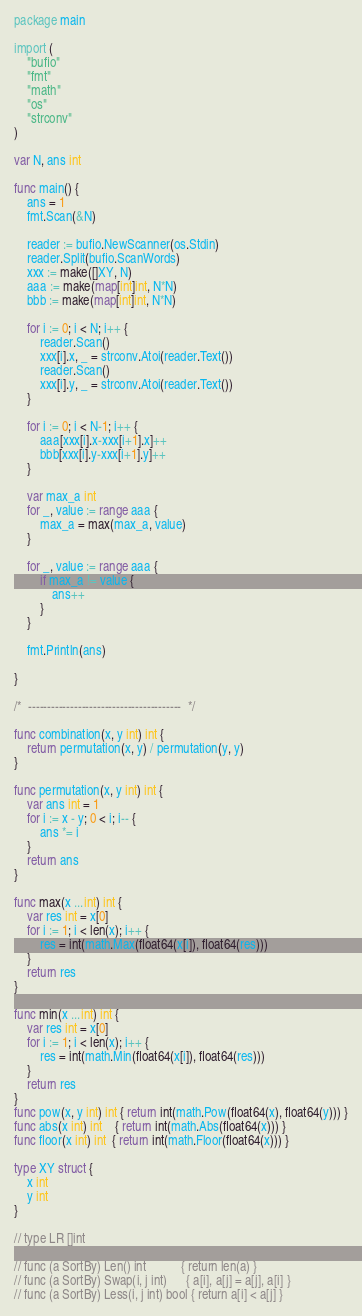Convert code to text. <code><loc_0><loc_0><loc_500><loc_500><_Go_>package main

import (
	"bufio"
	"fmt"
	"math"
	"os"
	"strconv"
)

var N, ans int

func main() {
	ans = 1
	fmt.Scan(&N)

	reader := bufio.NewScanner(os.Stdin)
	reader.Split(bufio.ScanWords)
	xxx := make([]XY, N)
	aaa := make(map[int]int, N*N)
	bbb := make(map[int]int, N*N)

	for i := 0; i < N; i++ {
		reader.Scan()
		xxx[i].x, _ = strconv.Atoi(reader.Text())
		reader.Scan()
		xxx[i].y, _ = strconv.Atoi(reader.Text())
	}

	for i := 0; i < N-1; i++ {
		aaa[xxx[i].x-xxx[i+1].x]++
		bbb[xxx[i].y-xxx[i+1].y]++
	}

	var max_a int
	for _, value := range aaa {
		max_a = max(max_a, value)
	}

	for _, value := range aaa {
		if max_a != value {
			ans++
		}
	}

	fmt.Println(ans)

}

/*  ----------------------------------------  */

func combination(x, y int) int {
	return permutation(x, y) / permutation(y, y)
}

func permutation(x, y int) int {
	var ans int = 1
	for i := x - y; 0 < i; i-- {
		ans *= i
	}
	return ans
}

func max(x ...int) int {
	var res int = x[0]
	for i := 1; i < len(x); i++ {
		res = int(math.Max(float64(x[i]), float64(res)))
	}
	return res
}

func min(x ...int) int {
	var res int = x[0]
	for i := 1; i < len(x); i++ {
		res = int(math.Min(float64(x[i]), float64(res)))
	}
	return res
}
func pow(x, y int) int { return int(math.Pow(float64(x), float64(y))) }
func abs(x int) int    { return int(math.Abs(float64(x))) }
func floor(x int) int  { return int(math.Floor(float64(x))) }

type XY struct {
	x int
	y int
}

// type LR []int

// func (a SortBy) Len() int           { return len(a) }
// func (a SortBy) Swap(i, j int)      { a[i], a[j] = a[j], a[i] }
// func (a SortBy) Less(i, j int) bool { return a[i] < a[j] }
</code> 